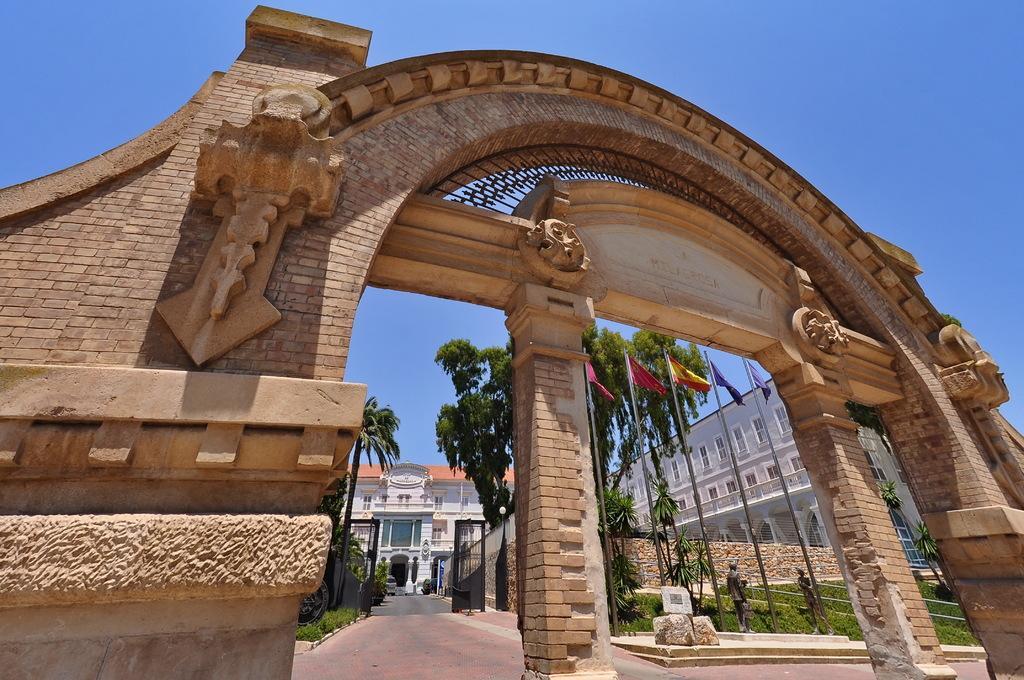Please provide a concise description of this image. In this image there is an arch in the foreground. In the background there is a building. In the middle there is a path, Beside the path there are trees. There are flags in the ground. At the top there is sky. On the right side there is a building with the windows. 